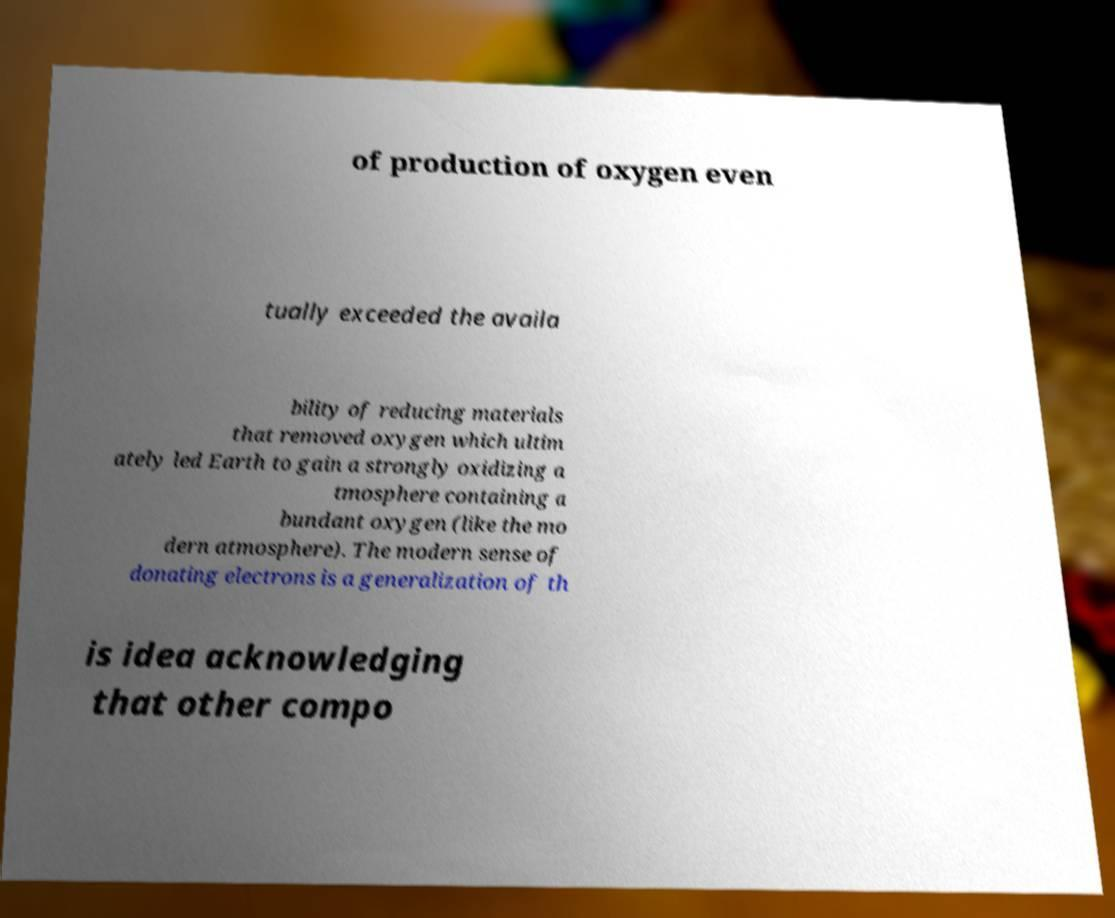There's text embedded in this image that I need extracted. Can you transcribe it verbatim? of production of oxygen even tually exceeded the availa bility of reducing materials that removed oxygen which ultim ately led Earth to gain a strongly oxidizing a tmosphere containing a bundant oxygen (like the mo dern atmosphere). The modern sense of donating electrons is a generalization of th is idea acknowledging that other compo 